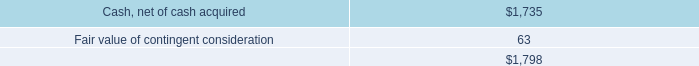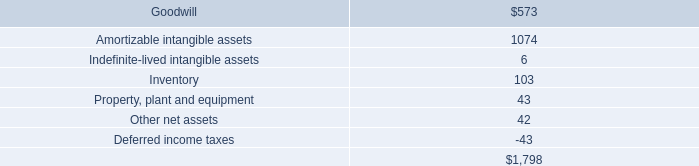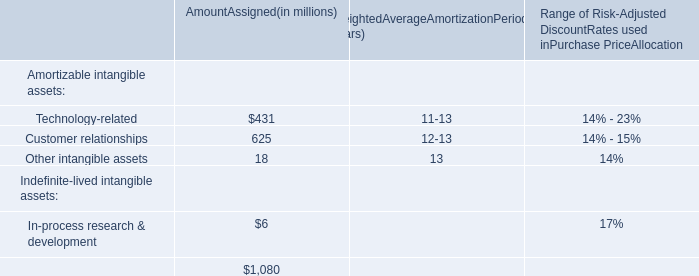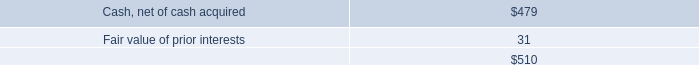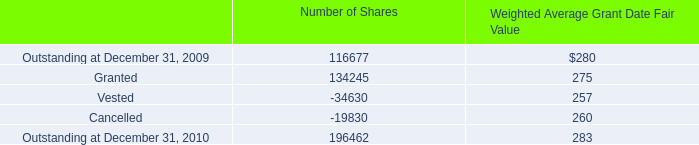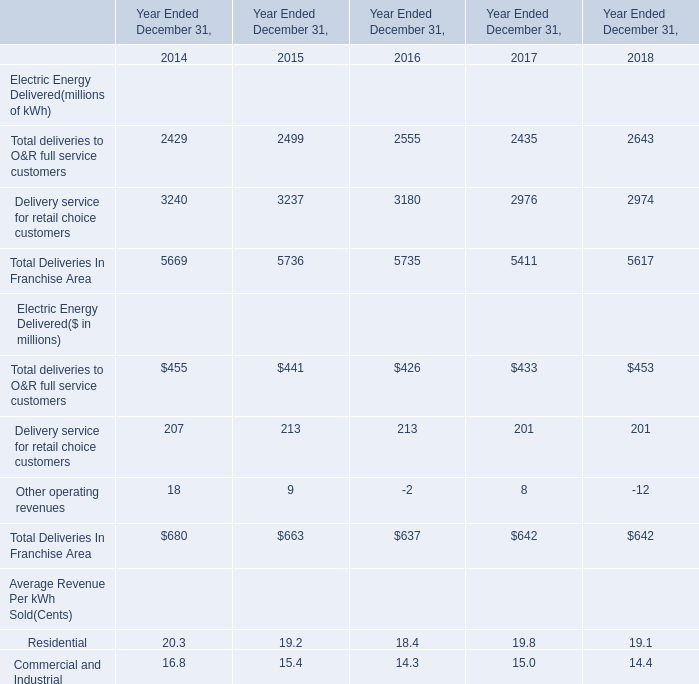What is the average amount of Cash, net of cash acquired, and Vested of Number of Shares ? 
Computations: ((1735.0 + 34630.0) / 2)
Answer: 18182.5. 